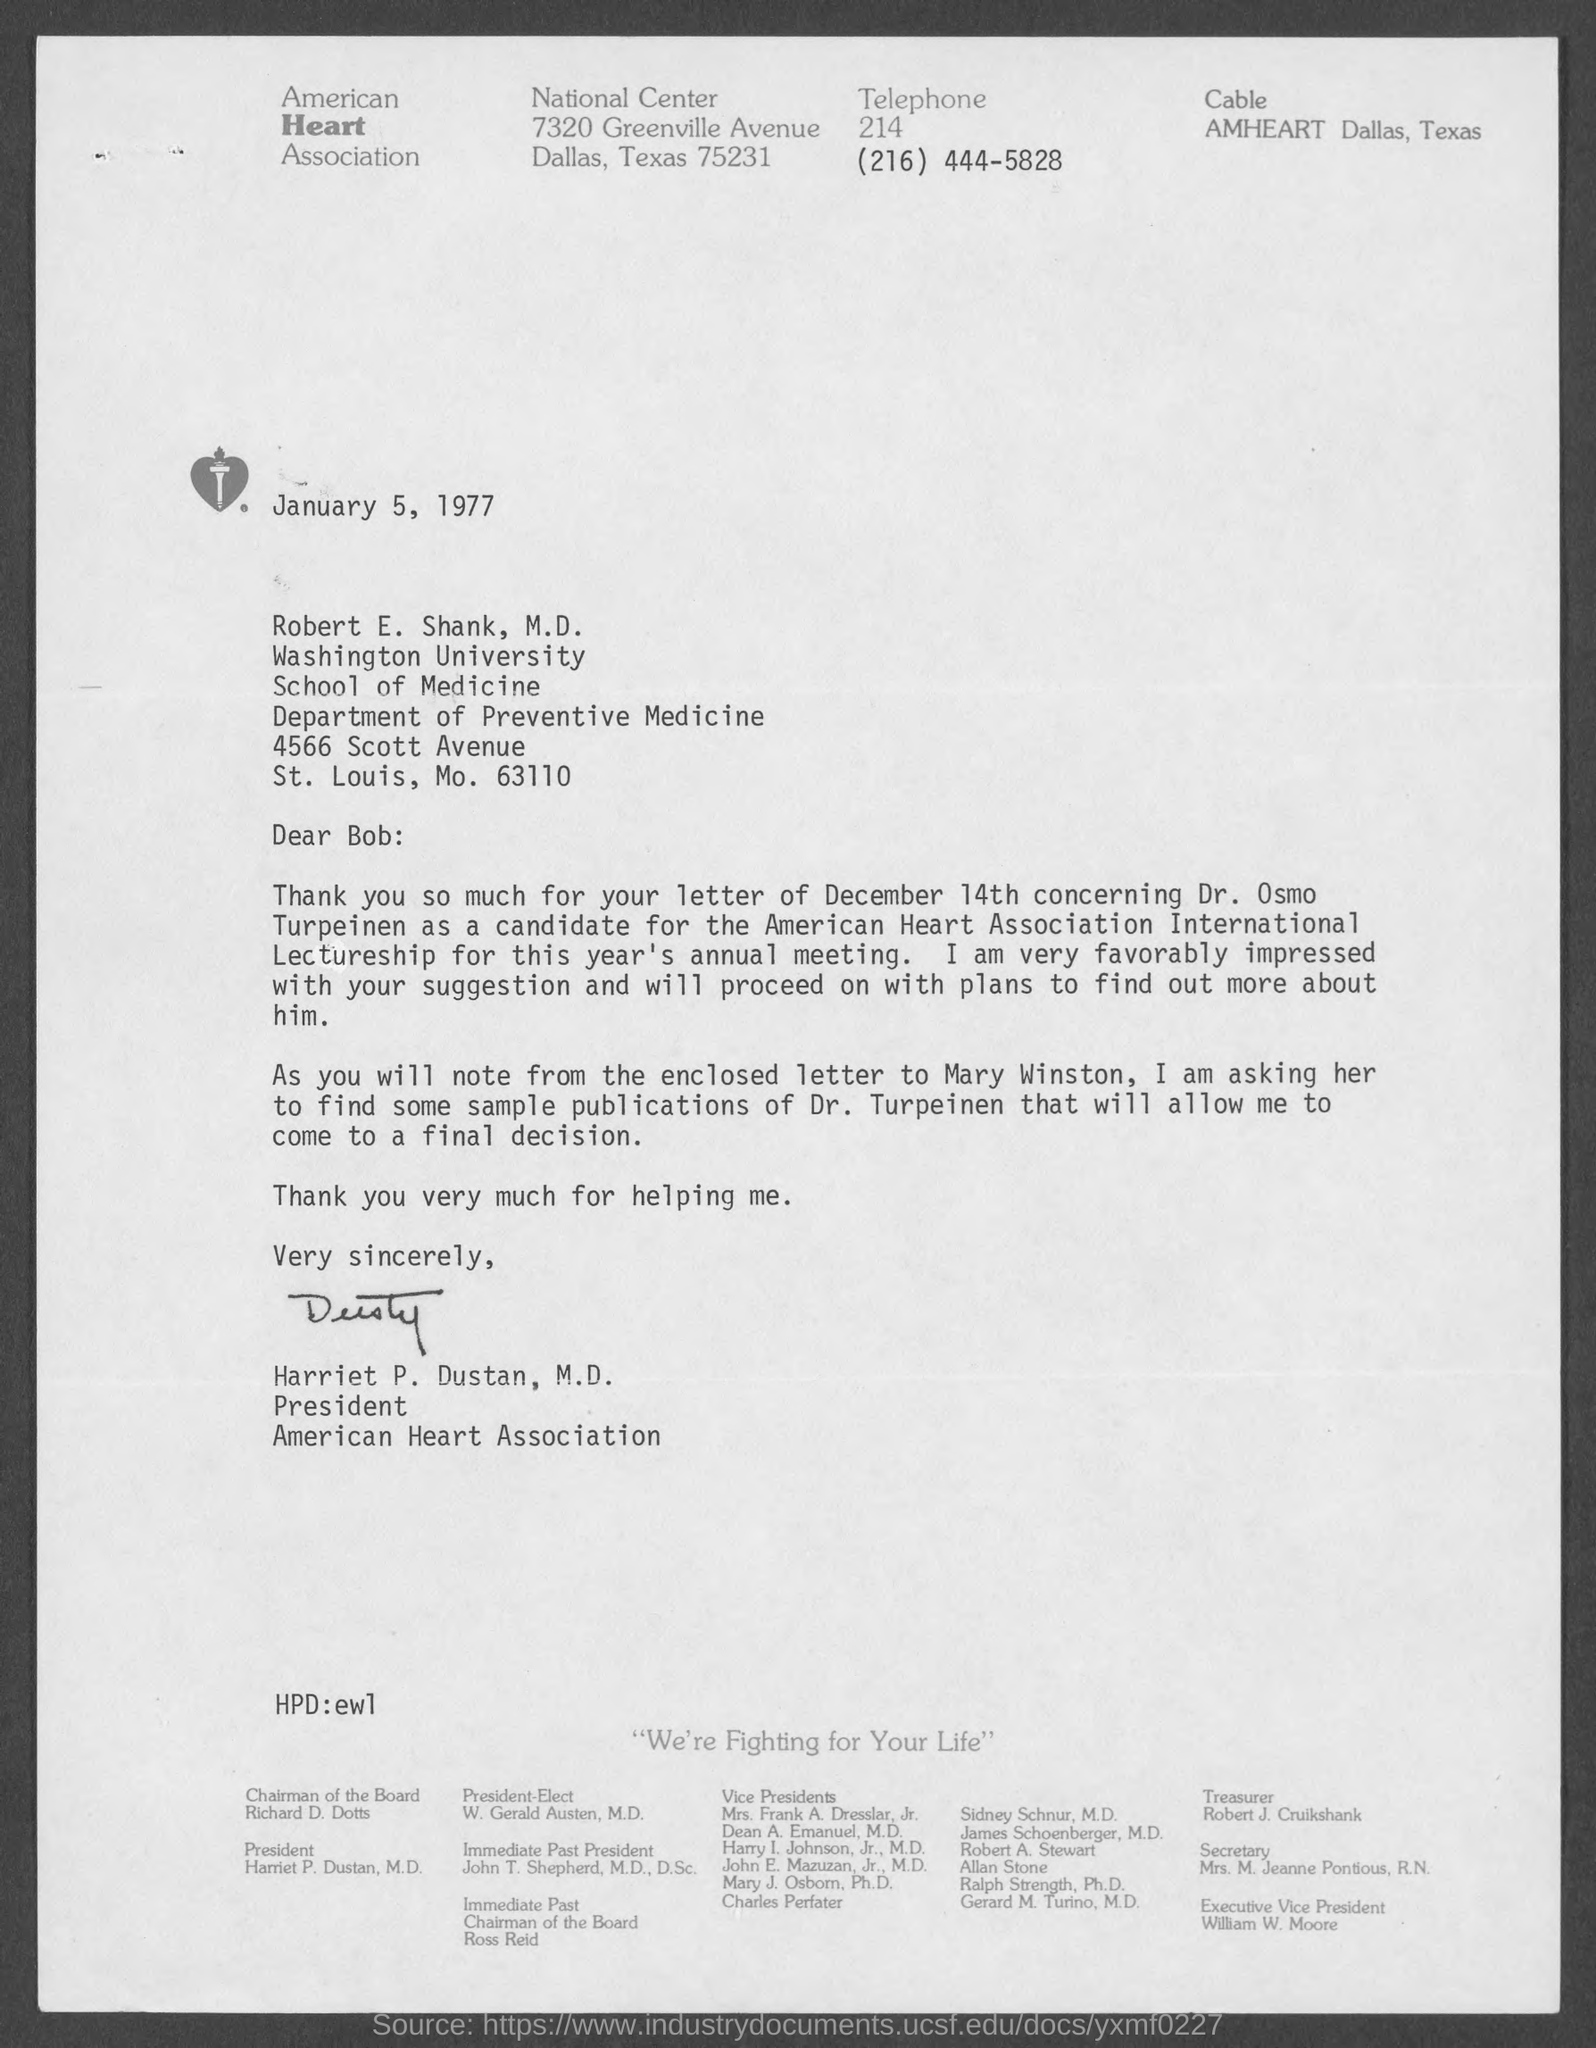What is the date on the document?
Give a very brief answer. January 5, 1977. To Whom is this letter addressed to?
Your response must be concise. Robert E. Shank, M.D. Who is this letter from?
Offer a terse response. Harriet P. Dustan, M.D. The letter of December 14th was concerning whom?
Your answer should be compact. Dr. Osmo Turpeinen. 